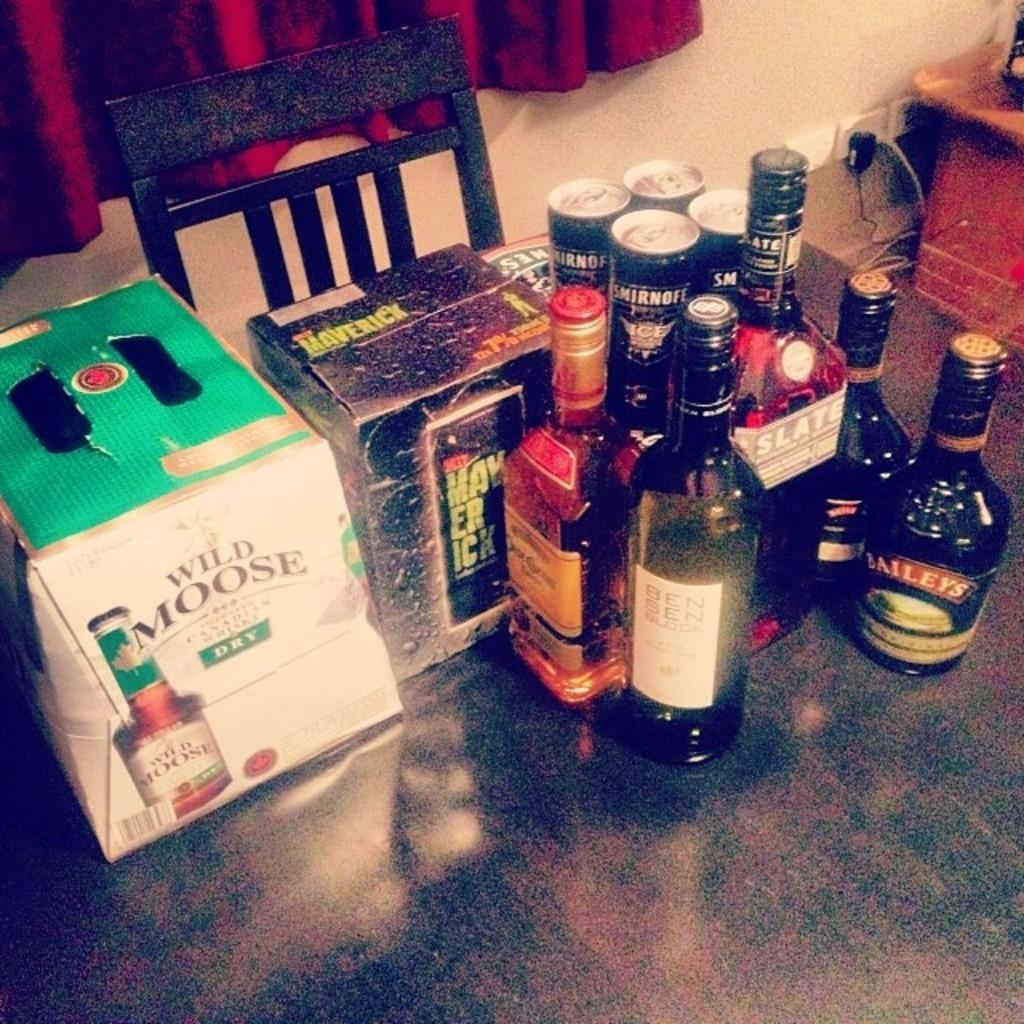<image>
Create a compact narrative representing the image presented. a collection of liquors including two bottles of Baileys 